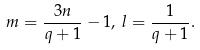<formula> <loc_0><loc_0><loc_500><loc_500>m = \frac { 3 n } { q + 1 } - 1 , \, l = \frac { 1 } { q + 1 } .</formula> 